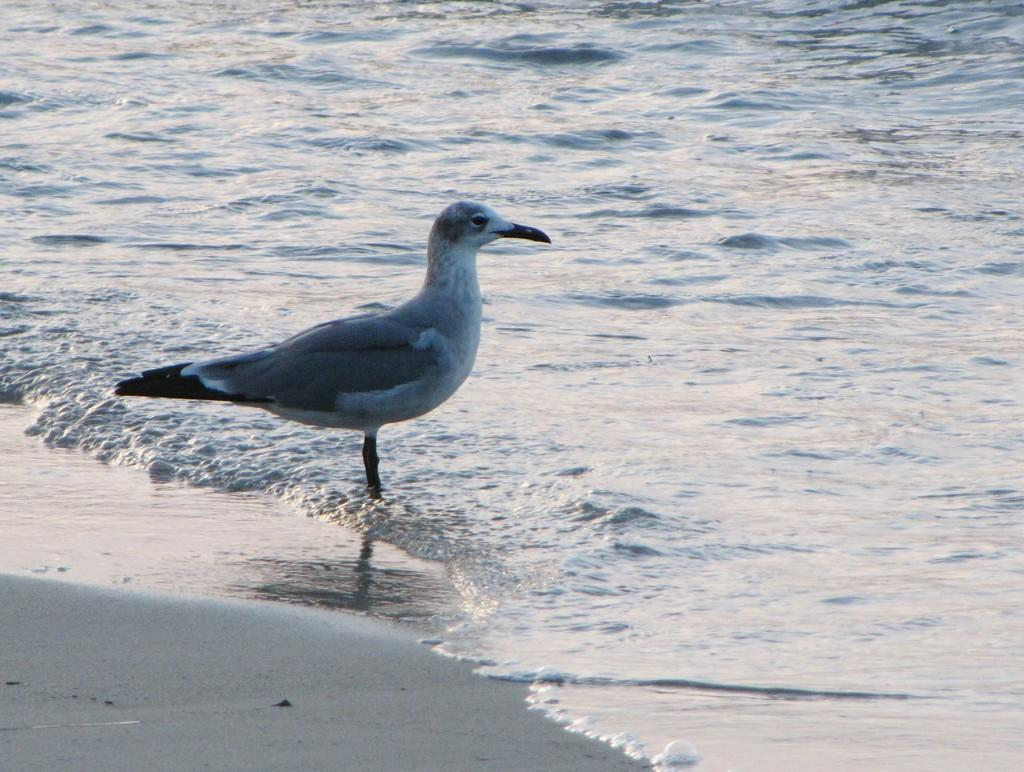What type of animal is in the image? There is a bird in the image. Where is the bird located in the image? The bird is standing in the water. What type of produce is being served at the bird's party in the image? There is no party or produce present in the image; it features a bird standing in the water. 